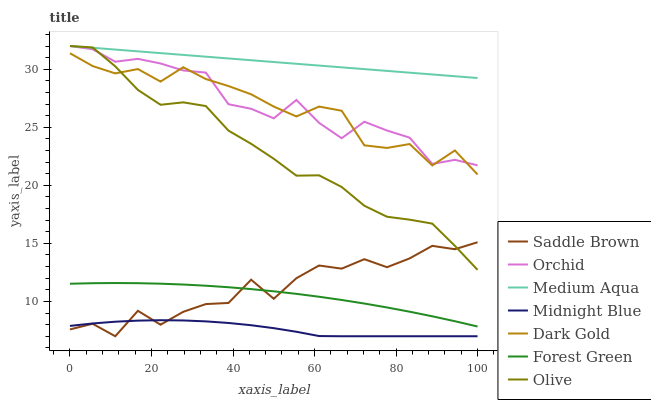Does Midnight Blue have the minimum area under the curve?
Answer yes or no. Yes. Does Medium Aqua have the maximum area under the curve?
Answer yes or no. Yes. Does Dark Gold have the minimum area under the curve?
Answer yes or no. No. Does Dark Gold have the maximum area under the curve?
Answer yes or no. No. Is Medium Aqua the smoothest?
Answer yes or no. Yes. Is Saddle Brown the roughest?
Answer yes or no. Yes. Is Dark Gold the smoothest?
Answer yes or no. No. Is Dark Gold the roughest?
Answer yes or no. No. Does Dark Gold have the lowest value?
Answer yes or no. No. Does Orchid have the highest value?
Answer yes or no. Yes. Does Dark Gold have the highest value?
Answer yes or no. No. Is Midnight Blue less than Olive?
Answer yes or no. Yes. Is Dark Gold greater than Midnight Blue?
Answer yes or no. Yes. Does Olive intersect Saddle Brown?
Answer yes or no. Yes. Is Olive less than Saddle Brown?
Answer yes or no. No. Is Olive greater than Saddle Brown?
Answer yes or no. No. Does Midnight Blue intersect Olive?
Answer yes or no. No. 